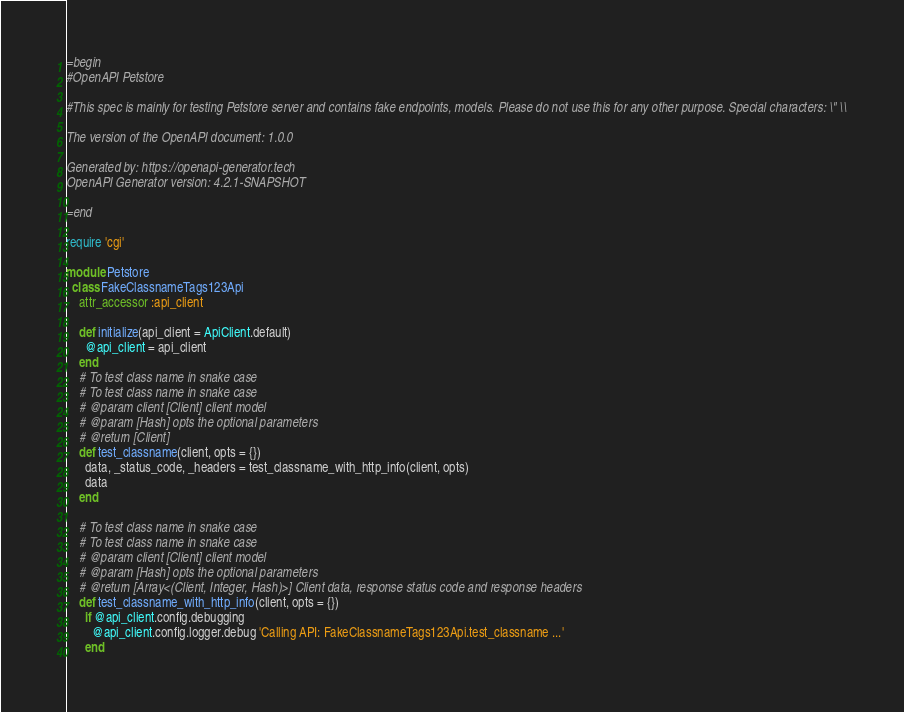<code> <loc_0><loc_0><loc_500><loc_500><_Ruby_>=begin
#OpenAPI Petstore

#This spec is mainly for testing Petstore server and contains fake endpoints, models. Please do not use this for any other purpose. Special characters: \" \\

The version of the OpenAPI document: 1.0.0

Generated by: https://openapi-generator.tech
OpenAPI Generator version: 4.2.1-SNAPSHOT

=end

require 'cgi'

module Petstore
  class FakeClassnameTags123Api
    attr_accessor :api_client

    def initialize(api_client = ApiClient.default)
      @api_client = api_client
    end
    # To test class name in snake case
    # To test class name in snake case
    # @param client [Client] client model
    # @param [Hash] opts the optional parameters
    # @return [Client]
    def test_classname(client, opts = {})
      data, _status_code, _headers = test_classname_with_http_info(client, opts)
      data
    end

    # To test class name in snake case
    # To test class name in snake case
    # @param client [Client] client model
    # @param [Hash] opts the optional parameters
    # @return [Array<(Client, Integer, Hash)>] Client data, response status code and response headers
    def test_classname_with_http_info(client, opts = {})
      if @api_client.config.debugging
        @api_client.config.logger.debug 'Calling API: FakeClassnameTags123Api.test_classname ...'
      end</code> 